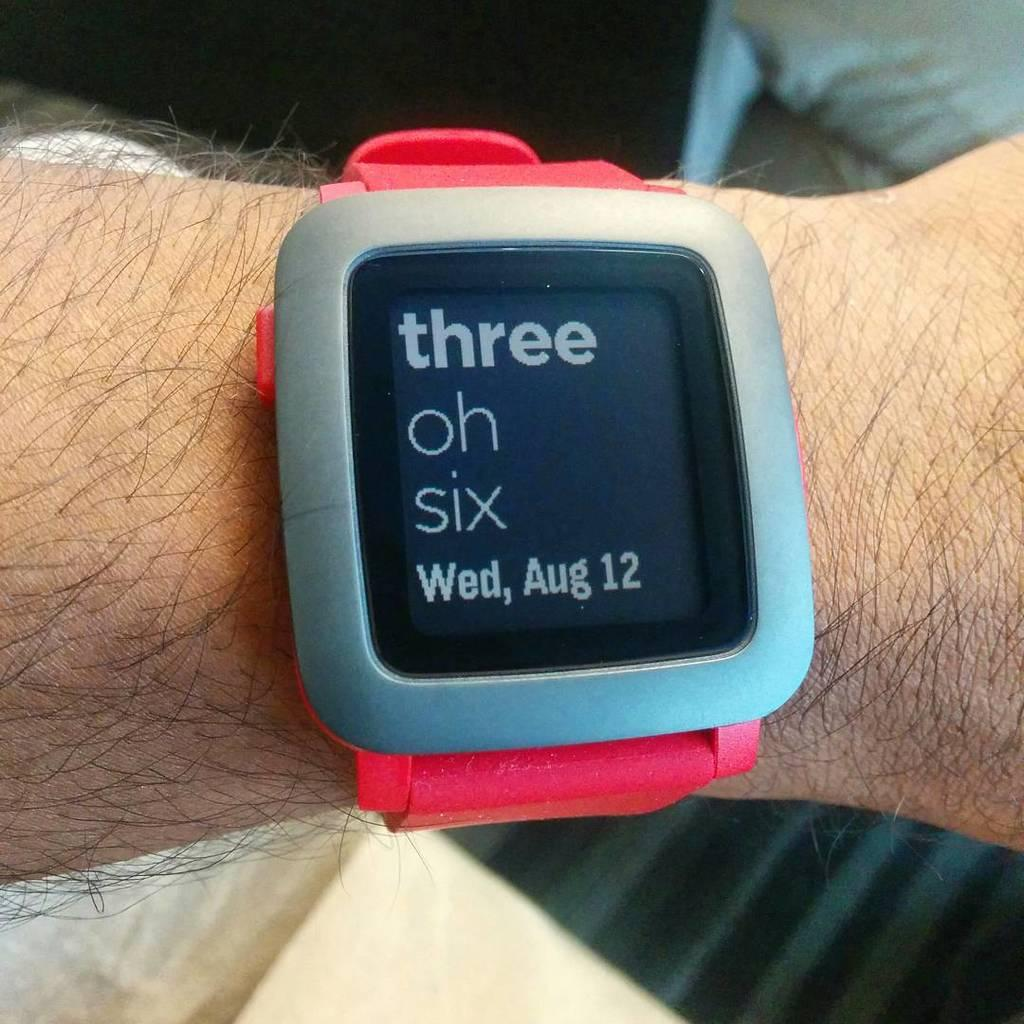<image>
Provide a brief description of the given image. A smart watch displays Three Oh Six on its display. 